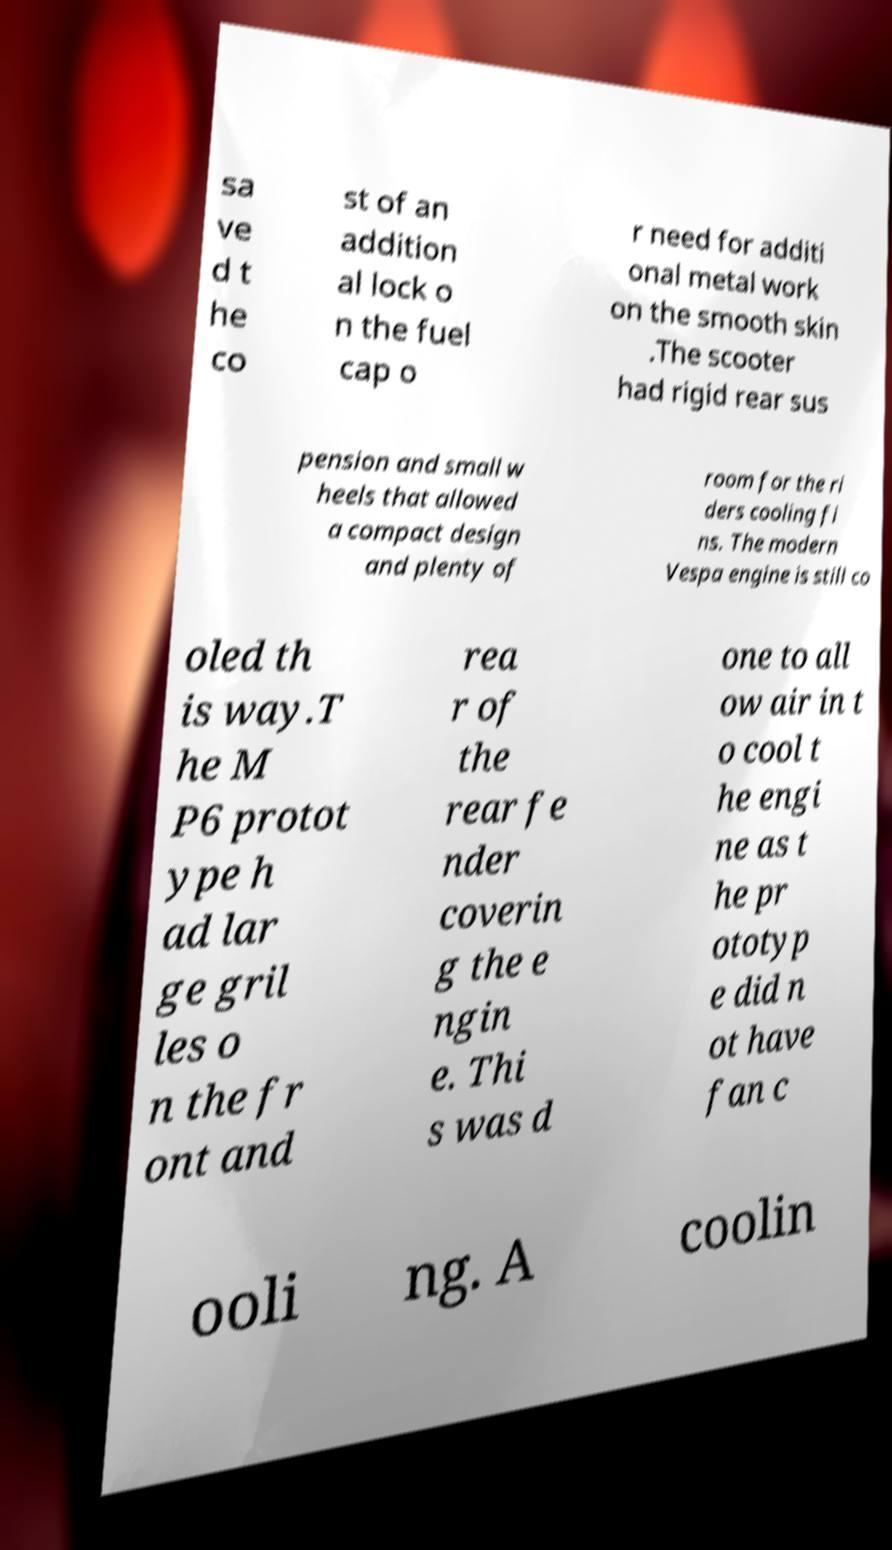Could you assist in decoding the text presented in this image and type it out clearly? sa ve d t he co st of an addition al lock o n the fuel cap o r need for additi onal metal work on the smooth skin .The scooter had rigid rear sus pension and small w heels that allowed a compact design and plenty of room for the ri ders cooling fi ns. The modern Vespa engine is still co oled th is way.T he M P6 protot ype h ad lar ge gril les o n the fr ont and rea r of the rear fe nder coverin g the e ngin e. Thi s was d one to all ow air in t o cool t he engi ne as t he pr ototyp e did n ot have fan c ooli ng. A coolin 